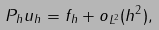Convert formula to latex. <formula><loc_0><loc_0><loc_500><loc_500>P _ { h } u _ { h } = f _ { h } + o _ { L ^ { 2 } } ( h ^ { 2 } ) ,</formula> 